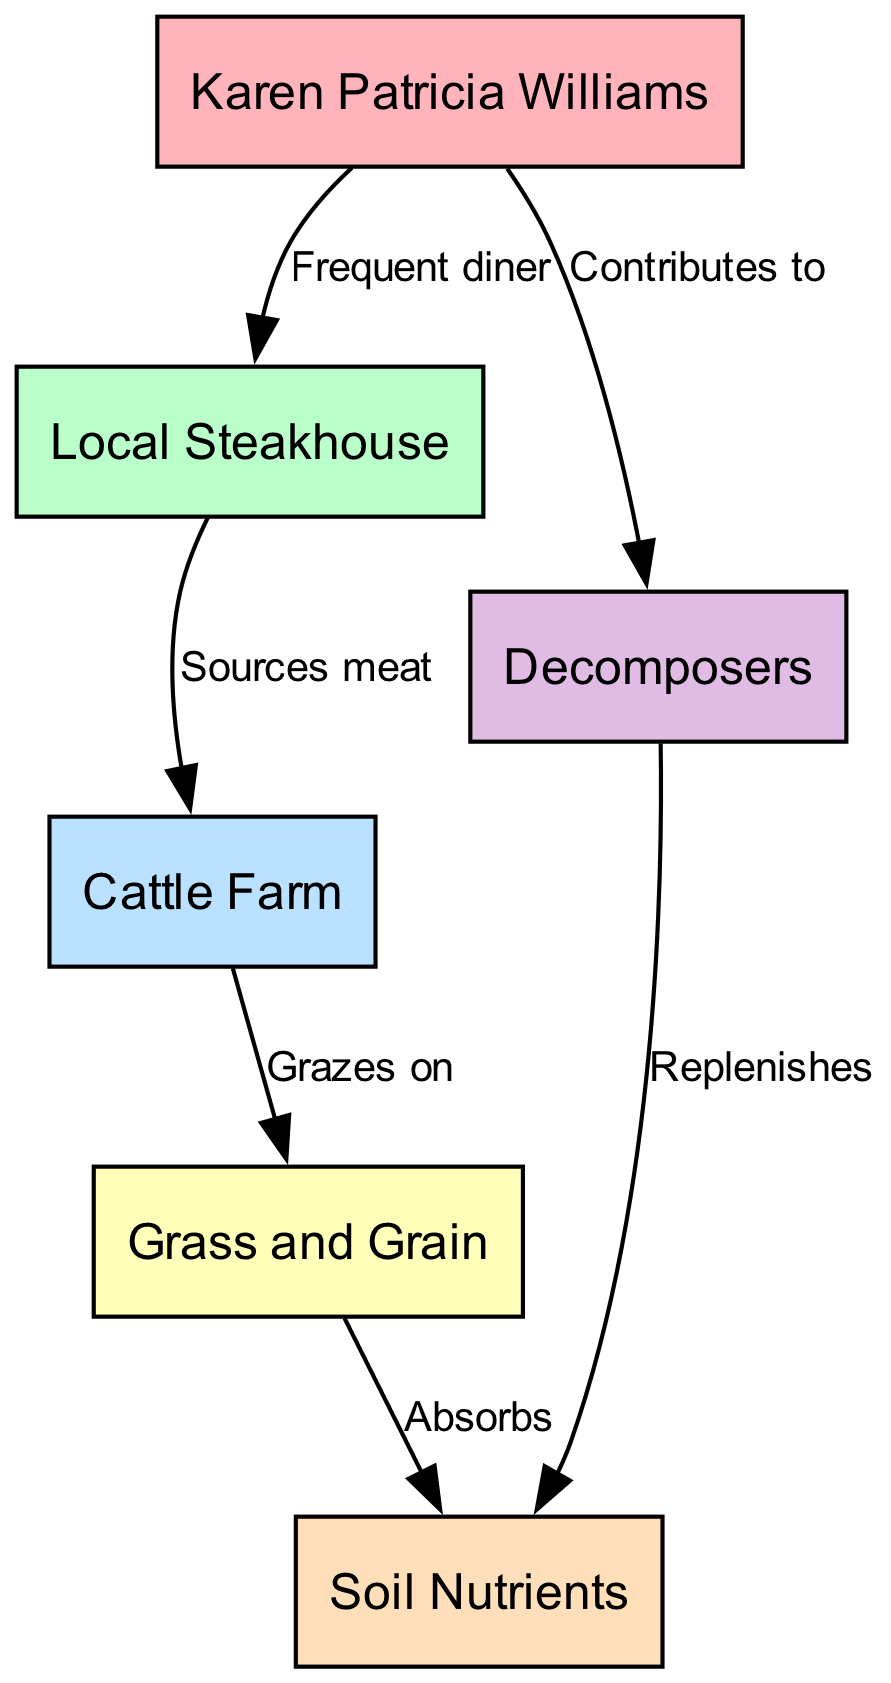What is the number of nodes in the diagram? The diagram presents a total of six distinct nodes, which include Karen Patricia Williams, Local Steakhouse, Cattle Farm, Grass and Grain, Soil Nutrients, and Decomposers.
Answer: 6 Who sources meat for the local steakhouse? The diagram indicates that the Cattle Farm is identified as the source of meat for the Local Steakhouse, establishing a direct relationship between these two nodes.
Answer: Cattle Farm What does Karen Patricia Williams contribute to? According to the diagram, Karen Patricia Williams contributes to the Decomposers, indicating her role in the nutrient cycle within the ecosystem.
Answer: Decomposers What do Grass and Grain absorb? The Grass and Grain node in the diagram is shown to absorb Soil Nutrients, which is essential for its growth and health within the ecosystem.
Answer: Soil Nutrients Which node grazes on Grass and Grain? The diagram reveals that the Cattle Farm is the entity that grazes on Grass and Grain, indicating a direct feeding relationship in the food chain.
Answer: Cattle Farm What is the label on the edge from the Local Steakhouse to the Cattle Farm? The edge labeling indicates that the Local Steakhouse "Sources meat" from the Cattle Farm, showing the flow of resources in the chain.
Answer: Sources meat How many edges connect Karen Patricia Williams to other nodes? There are two edges connecting Karen Patricia Williams to other nodes—one to the Local Steakhouse and another to the Decomposers.
Answer: 2 What role do decomposers play in the soil nutrient cycle? The diagram indicates that Decomposers "Replenish" Soil Nutrients, suggesting their essential function in cycling nutrients back into the soil.
Answer: Replenishes Which node is directly linked to both the Grass and Grain and the Soil Nutrients? Grass and Grain and Soil Nutrients are connected to the Cattle Farm, reflecting its role at the center of these relationships in the food chain.
Answer: Cattle Farm 